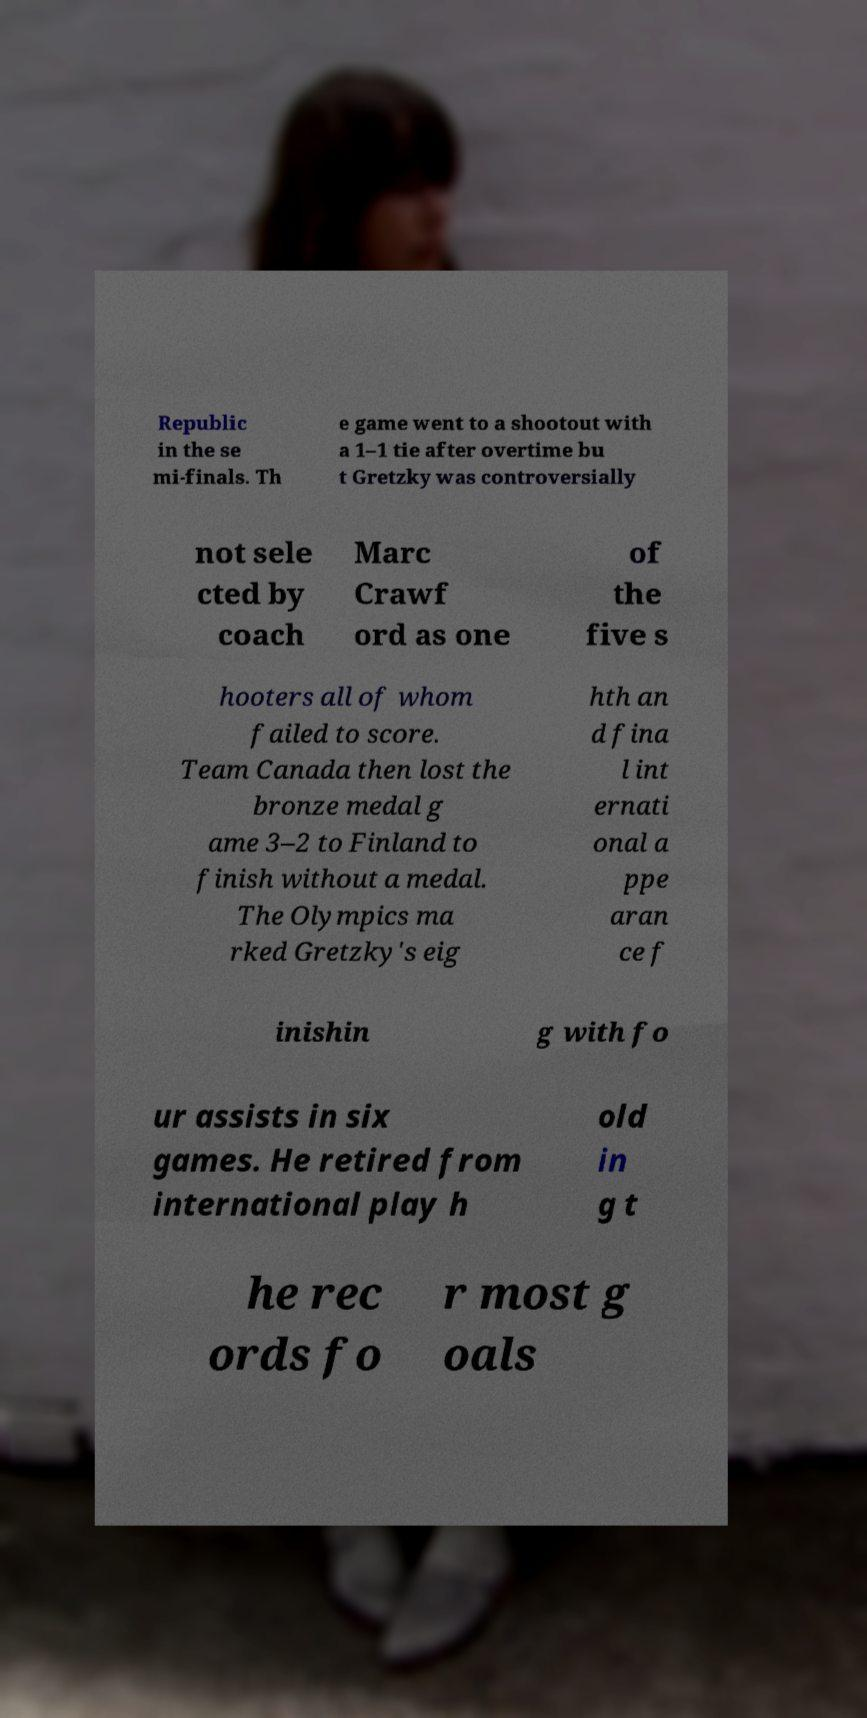Can you read and provide the text displayed in the image?This photo seems to have some interesting text. Can you extract and type it out for me? Republic in the se mi-finals. Th e game went to a shootout with a 1–1 tie after overtime bu t Gretzky was controversially not sele cted by coach Marc Crawf ord as one of the five s hooters all of whom failed to score. Team Canada then lost the bronze medal g ame 3–2 to Finland to finish without a medal. The Olympics ma rked Gretzky's eig hth an d fina l int ernati onal a ppe aran ce f inishin g with fo ur assists in six games. He retired from international play h old in g t he rec ords fo r most g oals 